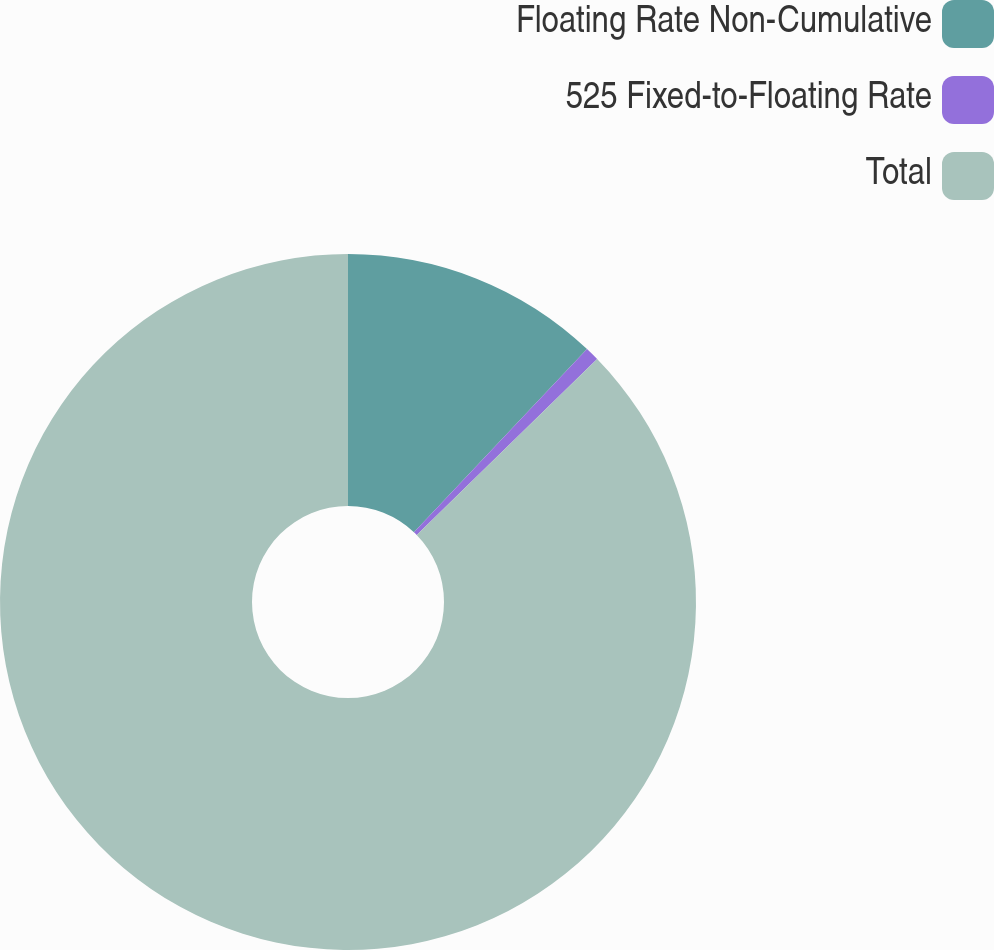<chart> <loc_0><loc_0><loc_500><loc_500><pie_chart><fcel>Floating Rate Non-Cumulative<fcel>525 Fixed-to-Floating Rate<fcel>Total<nl><fcel>12.05%<fcel>0.65%<fcel>87.3%<nl></chart> 